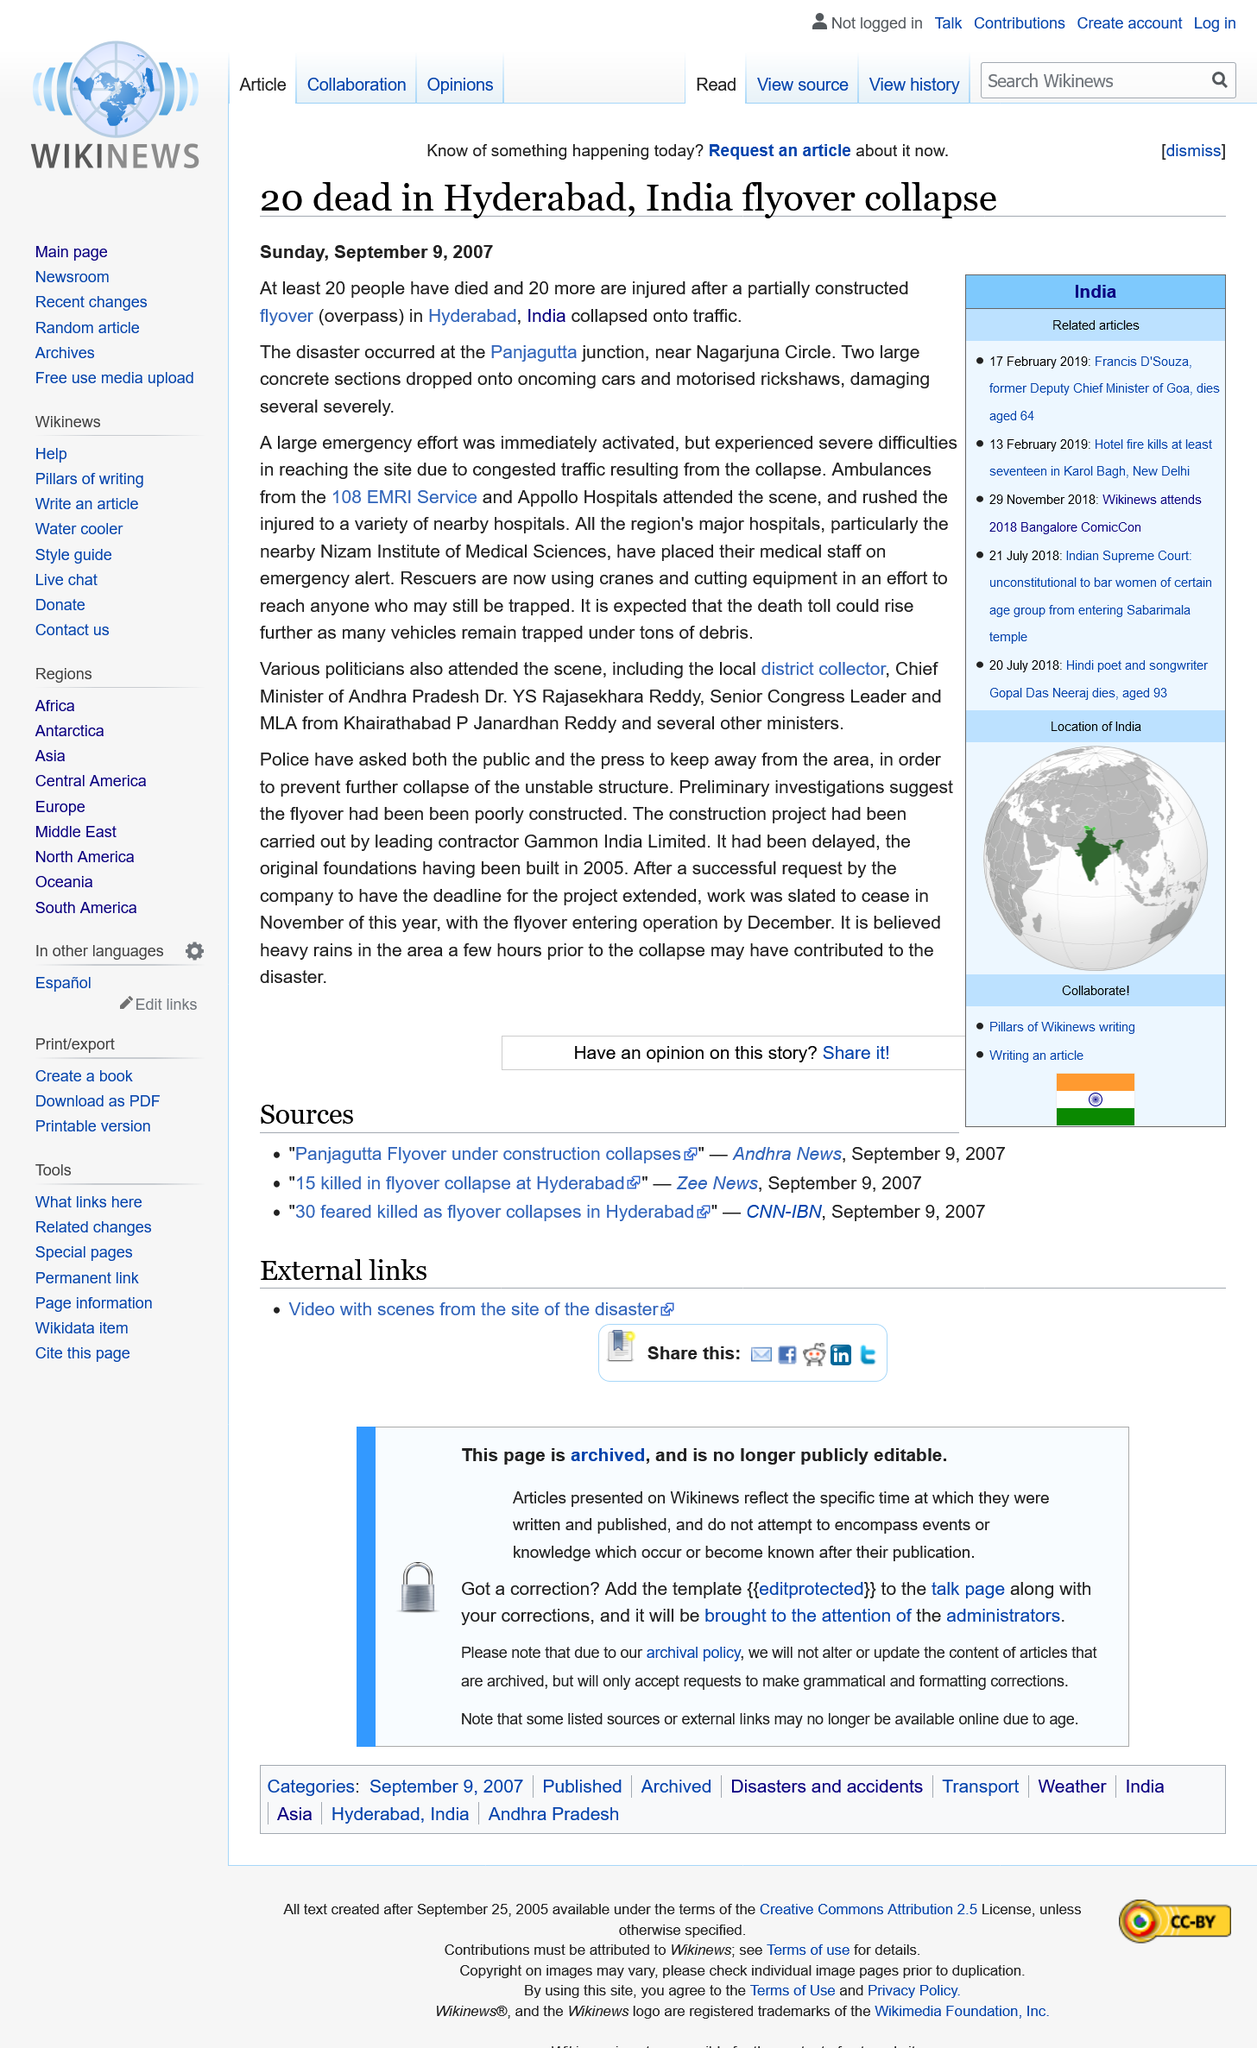Give some essential details in this illustration. This article was published on the 9th of September, 2007. Twenty people were injured in the collapse. The Panajagutta junction in Hyderabad, India was the location of the accident. 